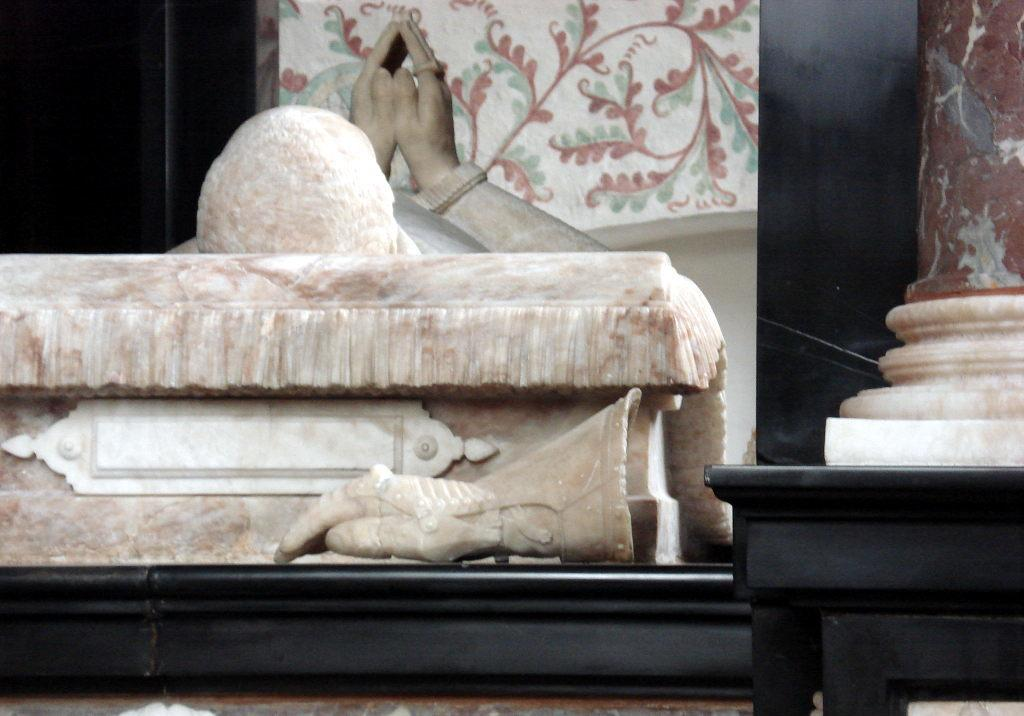What is the main subject of the image? The main subject of the image is a statue. Can you describe a specific feature of the statue? There is a depiction of a hand in the center of the image. What word does the statue say with its mouth in the image? There is no mouth on the statue in the image, so it cannot say any words. 